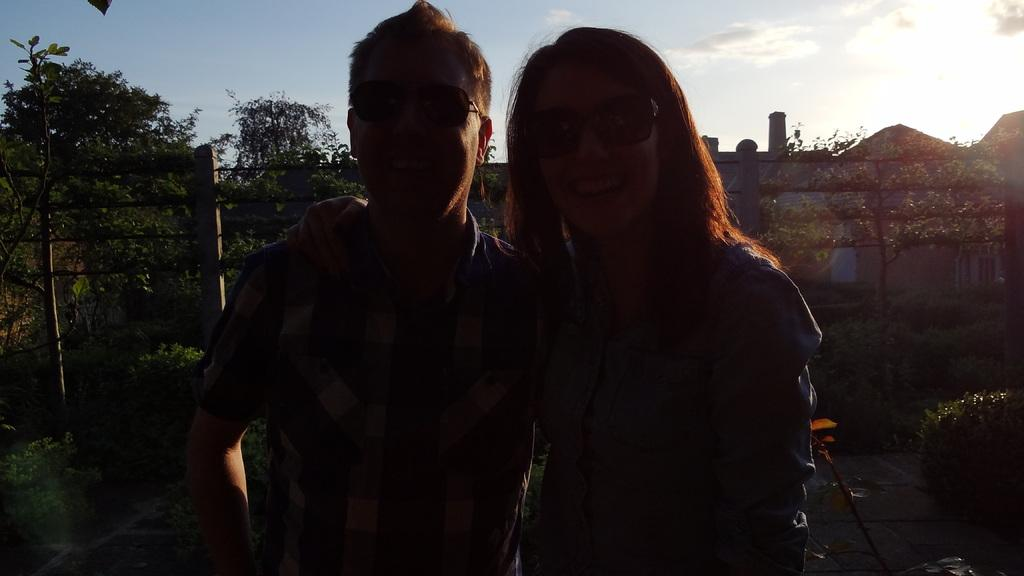Who are the people in the foreground of the image? There is a man and a woman in the foreground of the image. What can be seen in the image besides the people? There are plants and a boundary visible in the image. What is visible in the background of the image? The sky is visible in the image. What type of wing is attached to the rake in the image? There is no rake or wing present in the image. 